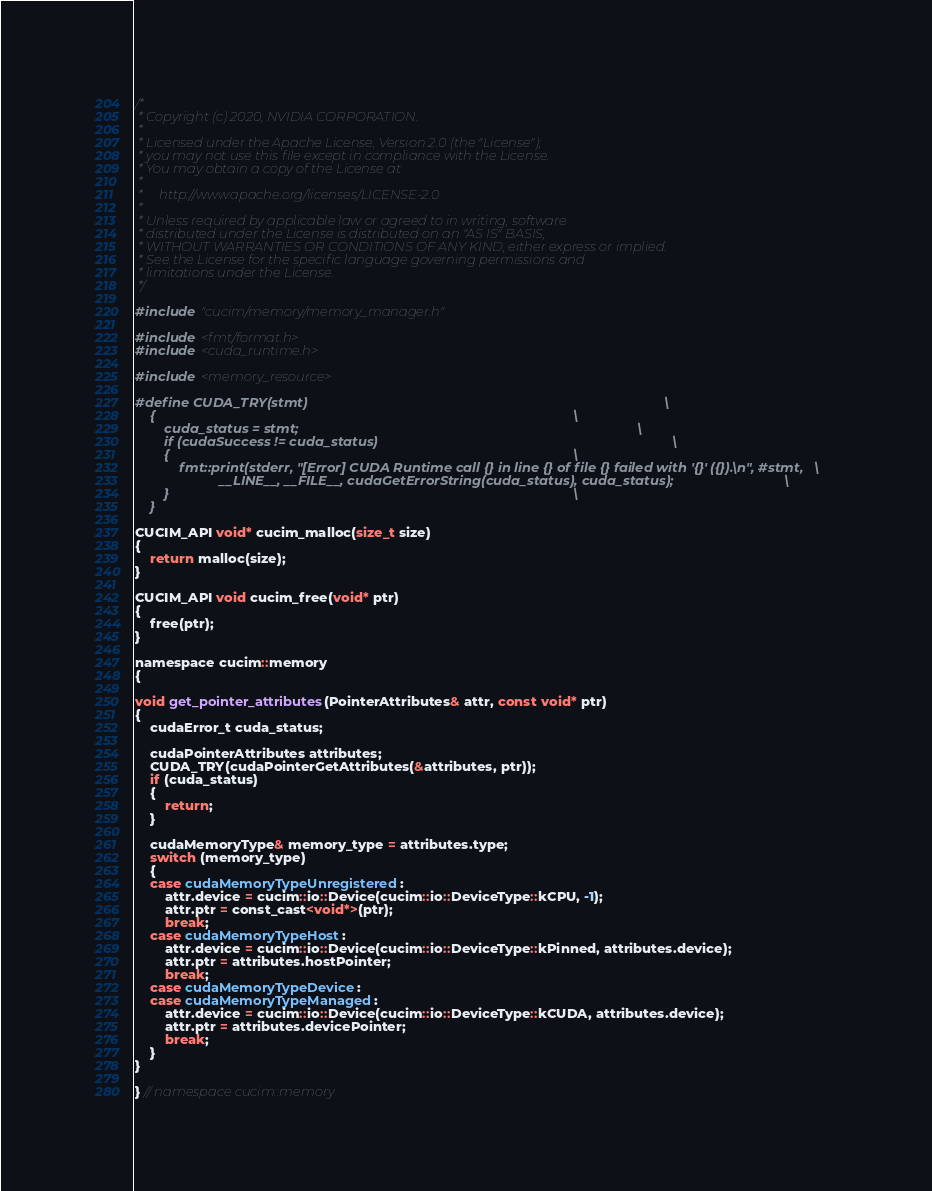<code> <loc_0><loc_0><loc_500><loc_500><_Cuda_>/*
 * Copyright (c) 2020, NVIDIA CORPORATION.
 *
 * Licensed under the Apache License, Version 2.0 (the "License");
 * you may not use this file except in compliance with the License.
 * You may obtain a copy of the License at
 *
 *     http://www.apache.org/licenses/LICENSE-2.0
 *
 * Unless required by applicable law or agreed to in writing, software
 * distributed under the License is distributed on an "AS IS" BASIS,
 * WITHOUT WARRANTIES OR CONDITIONS OF ANY KIND, either express or implied.
 * See the License for the specific language governing permissions and
 * limitations under the License.
 */

#include "cucim/memory/memory_manager.h"

#include <fmt/format.h>
#include <cuda_runtime.h>

#include <memory_resource>

#define CUDA_TRY(stmt)                                                                                                 \
    {                                                                                                                  \
        cuda_status = stmt;                                                                                            \
        if (cudaSuccess != cuda_status)                                                                                \
        {                                                                                                              \
            fmt::print(stderr, "[Error] CUDA Runtime call {} in line {} of file {} failed with '{}' ({}).\n", #stmt,   \
                       __LINE__, __FILE__, cudaGetErrorString(cuda_status), cuda_status);                              \
        }                                                                                                              \
    }

CUCIM_API void* cucim_malloc(size_t size)
{
    return malloc(size);
}

CUCIM_API void cucim_free(void* ptr)
{
    free(ptr);
}

namespace cucim::memory
{

void get_pointer_attributes(PointerAttributes& attr, const void* ptr)
{
    cudaError_t cuda_status;

    cudaPointerAttributes attributes;
    CUDA_TRY(cudaPointerGetAttributes(&attributes, ptr));
    if (cuda_status)
    {
        return;
    }

    cudaMemoryType& memory_type = attributes.type;
    switch (memory_type)
    {
    case cudaMemoryTypeUnregistered:
        attr.device = cucim::io::Device(cucim::io::DeviceType::kCPU, -1);
        attr.ptr = const_cast<void*>(ptr);
        break;
    case cudaMemoryTypeHost:
        attr.device = cucim::io::Device(cucim::io::DeviceType::kPinned, attributes.device);
        attr.ptr = attributes.hostPointer;
        break;
    case cudaMemoryTypeDevice:
    case cudaMemoryTypeManaged:
        attr.device = cucim::io::Device(cucim::io::DeviceType::kCUDA, attributes.device);
        attr.ptr = attributes.devicePointer;
        break;
    }
}

} // namespace cucim::memory</code> 